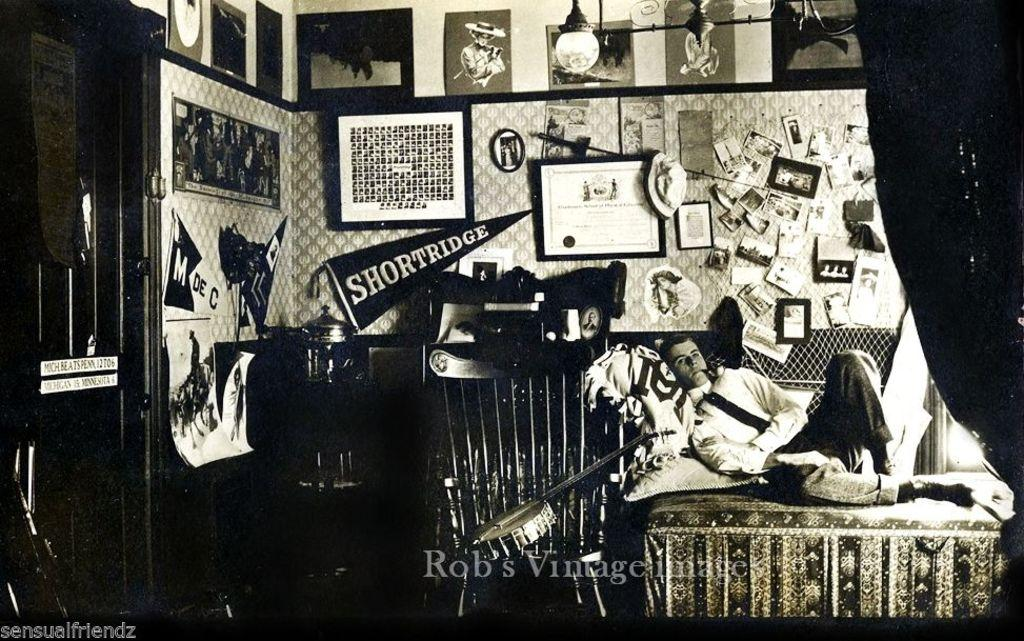What is the color scheme of the image? The image is black and white. Where was the image taken? The image was taken in a room. What can be seen on the walls of the room? There are multiple photo frames in the room. What is the man in the image doing? There is a man sitting on a bed in the image. What is the source of light in the room? There is a light on the top (ceiling) of the room. What type of dinner is being served in the image? There is no dinner present in the image; it is a black and white image of a man sitting on a bed in a room with photo frames on the walls and a light on the ceiling. Can you see any clouds in the image? There are no clouds visible in the image, as it is an indoor scene in a room. 